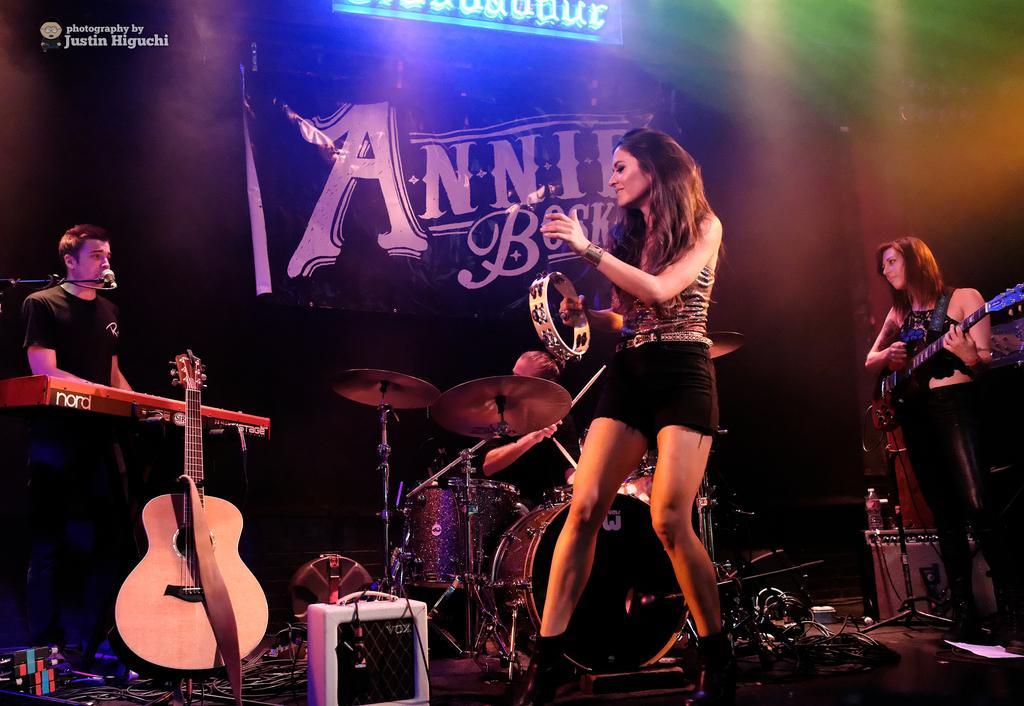How would you summarize this image in a sentence or two? on the left a man is singing in the microphone. In the middle a girl is dancing. In the right. A girl is standing and playing the guitar. 